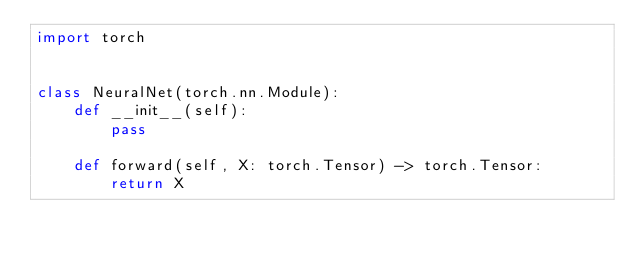<code> <loc_0><loc_0><loc_500><loc_500><_Python_>import torch


class NeuralNet(torch.nn.Module):
    def __init__(self):
        pass

    def forward(self, X: torch.Tensor) -> torch.Tensor:
        return X
</code> 